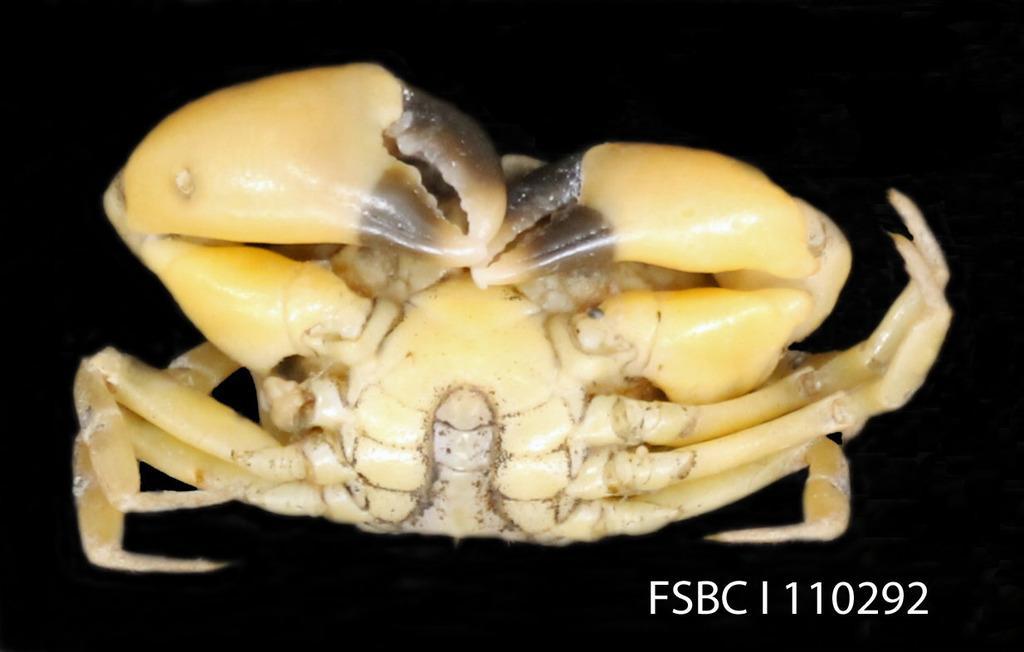Describe this image in one or two sentences. In this image we can see a crab which is in brown color. 